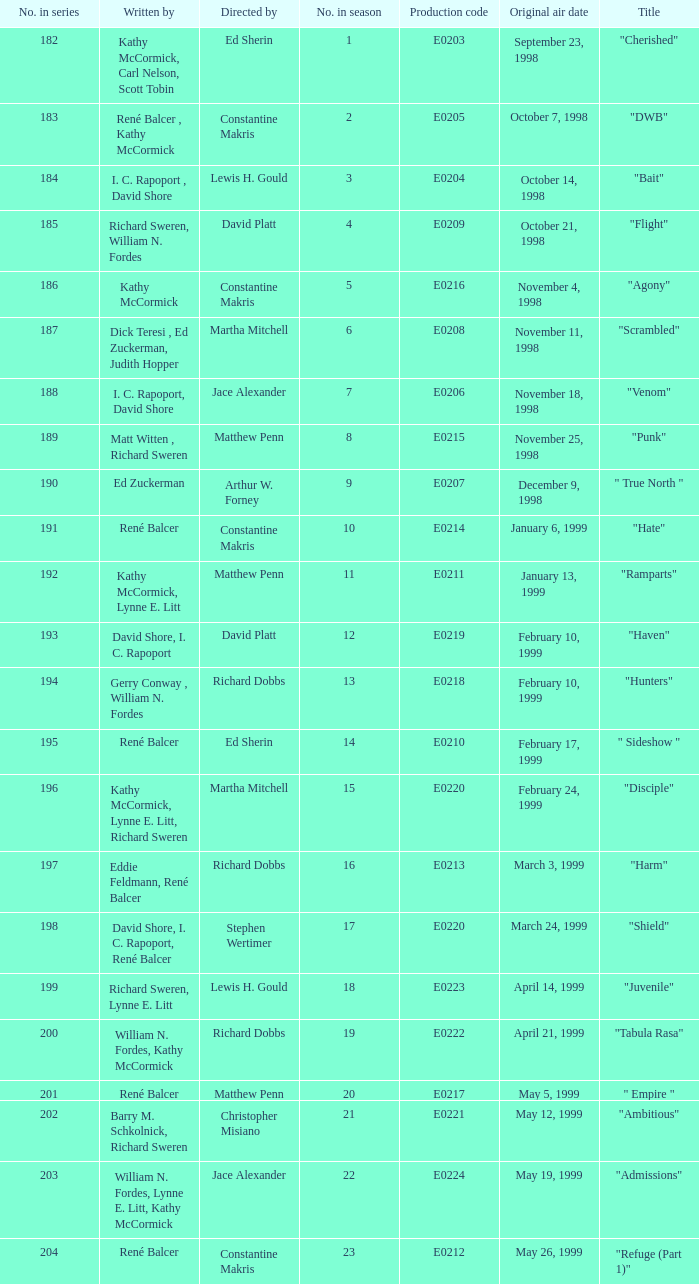The episode with the production code E0208 is directed by who? Martha Mitchell. 